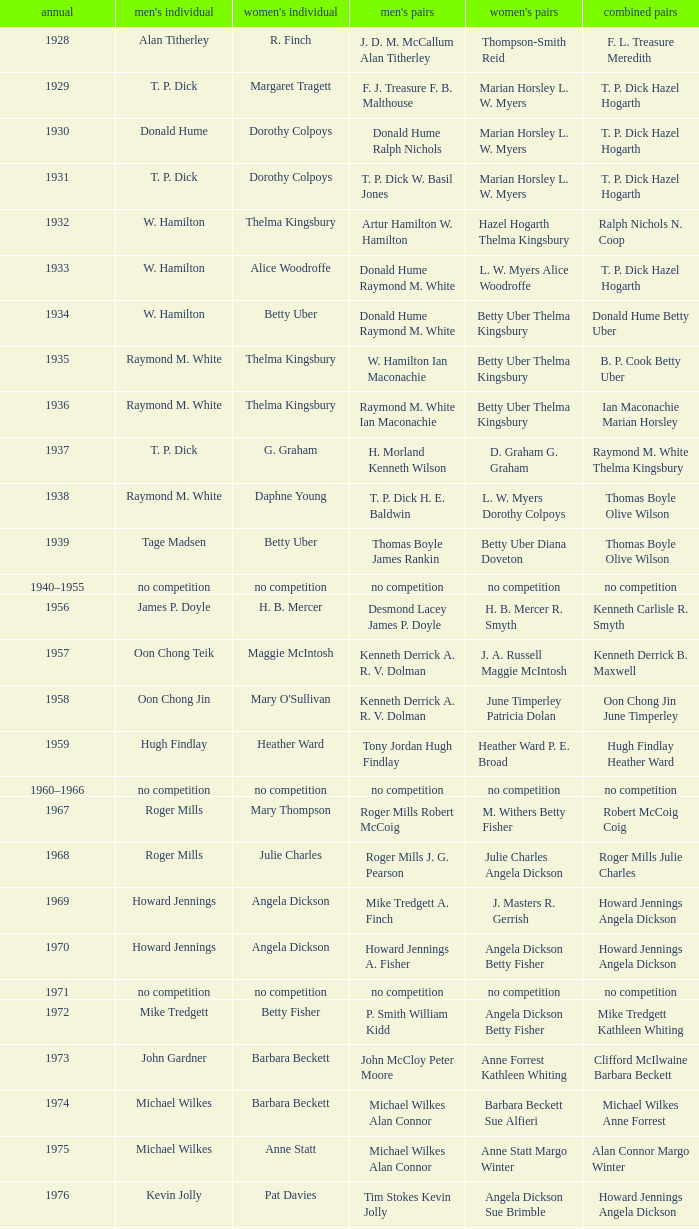Who won the Women's doubles in the year that Jesper Knudsen Nettie Nielsen won the Mixed doubles? Karen Beckman Sara Halsall. 